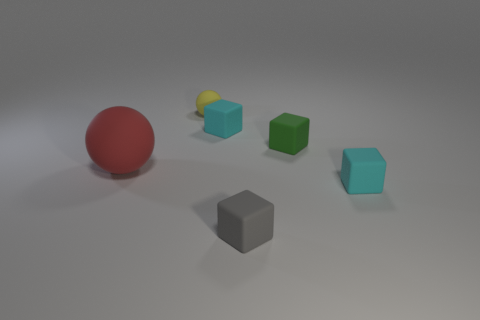Is there any other thing that has the same size as the red ball?
Ensure brevity in your answer.  No. Do the red object and the small yellow matte object have the same shape?
Give a very brief answer. Yes. There is a rubber sphere that is the same size as the green object; what color is it?
Keep it short and to the point. Yellow. Are there any small brown cubes?
Your response must be concise. No. What number of gray objects have the same size as the yellow thing?
Your response must be concise. 1. Is the number of cyan rubber cubes that are left of the large object the same as the number of purple metallic balls?
Your response must be concise. Yes. What number of matte things are both on the right side of the small sphere and left of the green matte object?
Give a very brief answer. 2. There is a red sphere that is the same material as the tiny gray block; what is its size?
Give a very brief answer. Large. How many small yellow rubber things are the same shape as the gray rubber object?
Your response must be concise. 0. Are there more red matte objects in front of the small yellow matte ball than big brown rubber things?
Keep it short and to the point. Yes. 